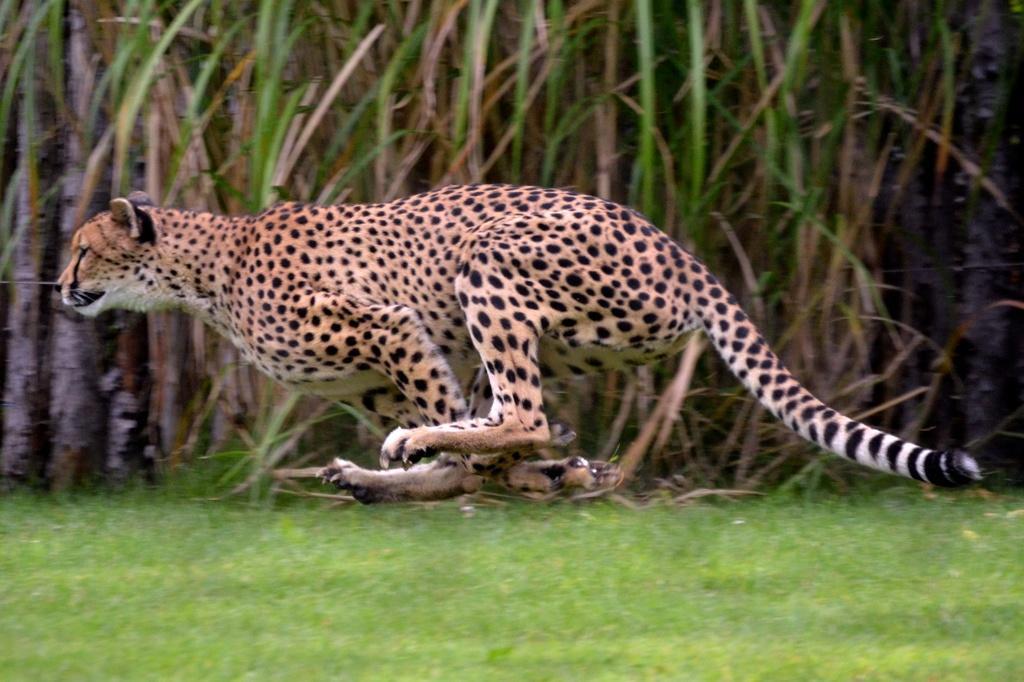Could you give a brief overview of what you see in this image? This picture shows a Leopard running and we see grass on the ground and few plants on the side and it is white, yellow and black in color. 